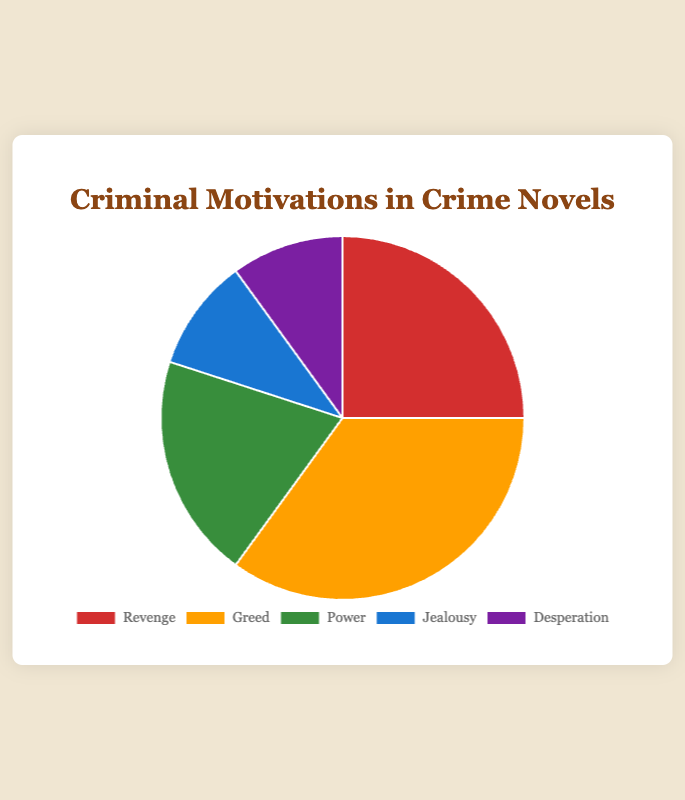What is the most common motivation for criminals in crime novels? The pie chart shows that "Greed" has the largest slice, indicating it is the most common motivation.
Answer: Greed Which motivation is less common: Power or Jealousy? The pie chart indicates that "Power" has a larger percentage (20%) than "Jealousy" (10%), making Jealousy less common.
Answer: Jealousy How many motivations have a percentage of 10%? The pie chart shows "Jealousy" and "Desperation" each with 10%, so there are two motivations.
Answer: 2 What is the combined percentage of motivations that are each 10%? Since both "Jealousy" and "Desperation" are 10% each, their combined percentage is 10% + 10% = 20%.
Answer: 20% Is the motivation "Revenge" greater than or less than the average percentage of all motivations? The average percentage of all motivations is (25% + 35% + 20% + 10% + 10%) / 5 = 100% / 5 = 20%. "Revenge" has a percentage of 25%, which is greater than the average.
Answer: Greater Which motivations are depicted with shades of red and yellow? The slice corresponding to "Revenge" is shown in red, while the slice for "Greed" is shown in yellow.
Answer: Revenge and Greed What is the difference in percentage between the most and least common motivations? The most common motivation is "Greed" (35%) and the least common motivations are "Jealousy" and "Desperation" (each 10%). The difference is 35% - 10% = 25%.
Answer: 25% What is the proportion of motivations linked to personal emotions (Revenge and Jealousy) compared to others? The percentage for "Revenge" is 25% and "Jealousy" is 10%, summing up to 35%. The percentage for other motivations is 100% - 35% = 65%. The proportion is 35% (personal emotions) to 65% (others).
Answer: 35% to 65% Which motivation shares the same percentage and what colors are these sections? The sections for "Jealousy" and "Desperation" both have 10%. They are shown in blue and purple respectively.
Answer: Jealousy and Desperation, blue and purple 